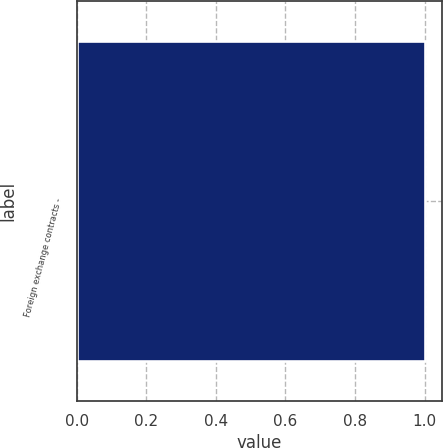Convert chart to OTSL. <chart><loc_0><loc_0><loc_500><loc_500><bar_chart><fcel>Foreign exchange contracts -<nl><fcel>1<nl></chart> 